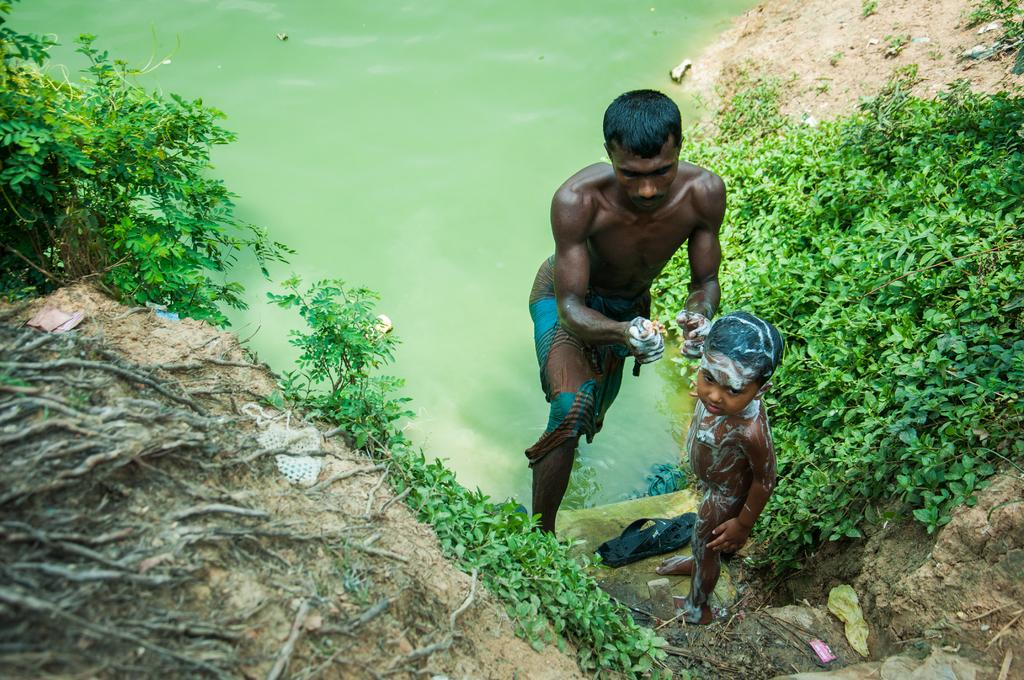What is the main element in the picture? There is water in the picture. Who is present near the water? There is a man and a boy standing beside the water. What else can be seen near the water? Creeps and plants are present near the water. What type of lunch is the ghost eating in the picture? There is no ghost present in the picture, so it is not possible to determine what, if any, lunch they might be eating. 